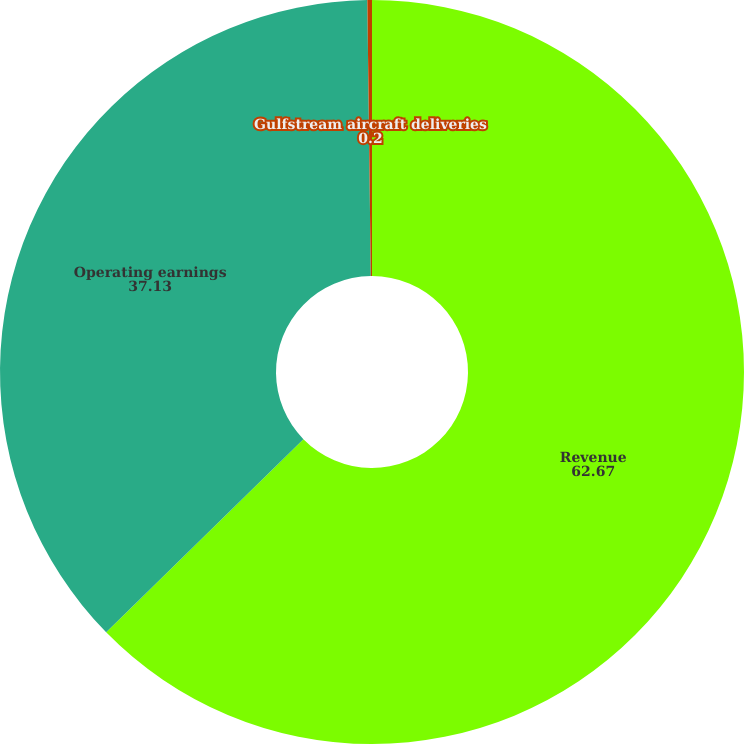Convert chart. <chart><loc_0><loc_0><loc_500><loc_500><pie_chart><fcel>Revenue<fcel>Operating earnings<fcel>Gulfstream aircraft deliveries<nl><fcel>62.67%<fcel>37.13%<fcel>0.2%<nl></chart> 